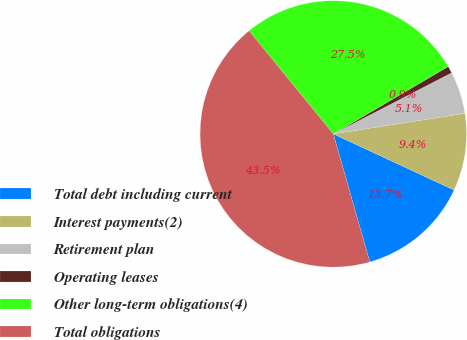Convert chart to OTSL. <chart><loc_0><loc_0><loc_500><loc_500><pie_chart><fcel>Total debt including current<fcel>Interest payments(2)<fcel>Retirement plan<fcel>Operating leases<fcel>Other long-term obligations(4)<fcel>Total obligations<nl><fcel>13.66%<fcel>9.39%<fcel>5.12%<fcel>0.86%<fcel>27.45%<fcel>43.52%<nl></chart> 